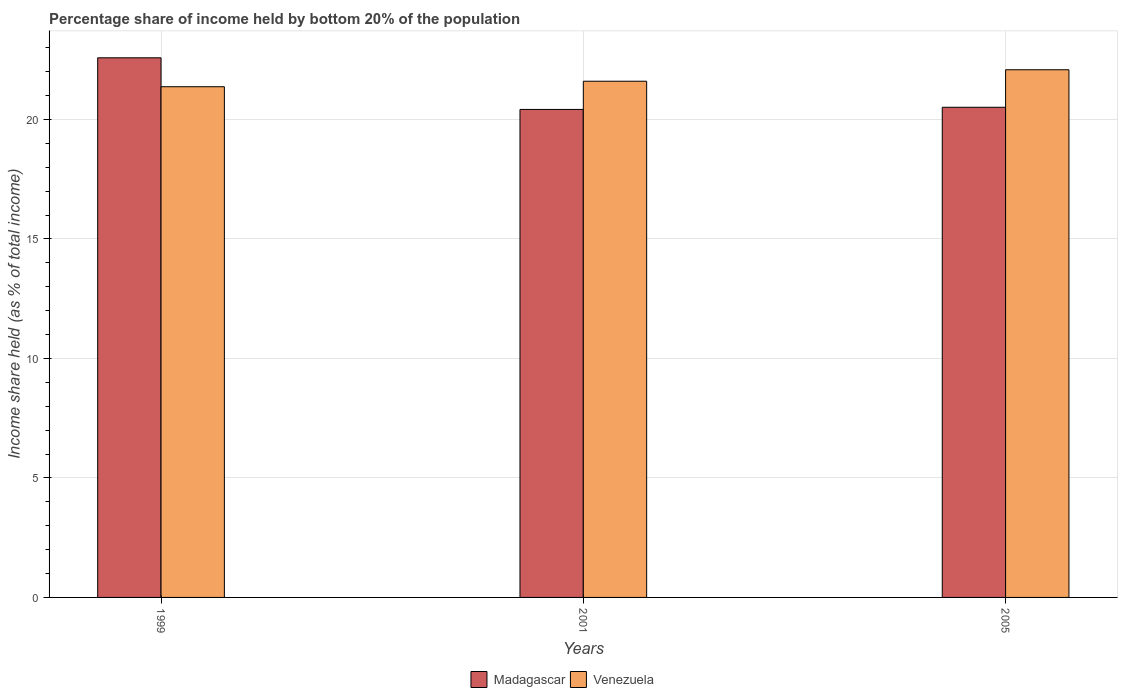Are the number of bars per tick equal to the number of legend labels?
Ensure brevity in your answer.  Yes. How many bars are there on the 3rd tick from the left?
Offer a terse response. 2. In how many cases, is the number of bars for a given year not equal to the number of legend labels?
Give a very brief answer. 0. What is the share of income held by bottom 20% of the population in Madagascar in 2005?
Offer a terse response. 20.51. Across all years, what is the maximum share of income held by bottom 20% of the population in Venezuela?
Your answer should be very brief. 22.08. Across all years, what is the minimum share of income held by bottom 20% of the population in Venezuela?
Your answer should be compact. 21.37. In which year was the share of income held by bottom 20% of the population in Venezuela maximum?
Ensure brevity in your answer.  2005. In which year was the share of income held by bottom 20% of the population in Madagascar minimum?
Your answer should be very brief. 2001. What is the total share of income held by bottom 20% of the population in Venezuela in the graph?
Give a very brief answer. 65.05. What is the difference between the share of income held by bottom 20% of the population in Madagascar in 1999 and that in 2001?
Make the answer very short. 2.16. What is the difference between the share of income held by bottom 20% of the population in Madagascar in 2005 and the share of income held by bottom 20% of the population in Venezuela in 2001?
Give a very brief answer. -1.09. What is the average share of income held by bottom 20% of the population in Venezuela per year?
Ensure brevity in your answer.  21.68. In the year 2005, what is the difference between the share of income held by bottom 20% of the population in Venezuela and share of income held by bottom 20% of the population in Madagascar?
Give a very brief answer. 1.57. In how many years, is the share of income held by bottom 20% of the population in Venezuela greater than 18 %?
Give a very brief answer. 3. What is the ratio of the share of income held by bottom 20% of the population in Venezuela in 1999 to that in 2005?
Ensure brevity in your answer.  0.97. Is the share of income held by bottom 20% of the population in Madagascar in 1999 less than that in 2001?
Your answer should be compact. No. Is the difference between the share of income held by bottom 20% of the population in Venezuela in 1999 and 2005 greater than the difference between the share of income held by bottom 20% of the population in Madagascar in 1999 and 2005?
Provide a short and direct response. No. What is the difference between the highest and the second highest share of income held by bottom 20% of the population in Venezuela?
Ensure brevity in your answer.  0.48. What is the difference between the highest and the lowest share of income held by bottom 20% of the population in Venezuela?
Keep it short and to the point. 0.71. Is the sum of the share of income held by bottom 20% of the population in Venezuela in 1999 and 2001 greater than the maximum share of income held by bottom 20% of the population in Madagascar across all years?
Your answer should be very brief. Yes. What does the 1st bar from the left in 1999 represents?
Provide a short and direct response. Madagascar. What does the 2nd bar from the right in 1999 represents?
Provide a short and direct response. Madagascar. How many years are there in the graph?
Give a very brief answer. 3. How are the legend labels stacked?
Make the answer very short. Horizontal. What is the title of the graph?
Your answer should be compact. Percentage share of income held by bottom 20% of the population. Does "Burkina Faso" appear as one of the legend labels in the graph?
Your answer should be compact. No. What is the label or title of the Y-axis?
Offer a terse response. Income share held (as % of total income). What is the Income share held (as % of total income) of Madagascar in 1999?
Give a very brief answer. 22.58. What is the Income share held (as % of total income) in Venezuela in 1999?
Ensure brevity in your answer.  21.37. What is the Income share held (as % of total income) in Madagascar in 2001?
Your response must be concise. 20.42. What is the Income share held (as % of total income) of Venezuela in 2001?
Your answer should be compact. 21.6. What is the Income share held (as % of total income) of Madagascar in 2005?
Your response must be concise. 20.51. What is the Income share held (as % of total income) in Venezuela in 2005?
Keep it short and to the point. 22.08. Across all years, what is the maximum Income share held (as % of total income) in Madagascar?
Offer a very short reply. 22.58. Across all years, what is the maximum Income share held (as % of total income) in Venezuela?
Your answer should be compact. 22.08. Across all years, what is the minimum Income share held (as % of total income) in Madagascar?
Your answer should be compact. 20.42. Across all years, what is the minimum Income share held (as % of total income) of Venezuela?
Your response must be concise. 21.37. What is the total Income share held (as % of total income) of Madagascar in the graph?
Offer a terse response. 63.51. What is the total Income share held (as % of total income) of Venezuela in the graph?
Offer a very short reply. 65.05. What is the difference between the Income share held (as % of total income) in Madagascar in 1999 and that in 2001?
Provide a short and direct response. 2.16. What is the difference between the Income share held (as % of total income) in Venezuela in 1999 and that in 2001?
Give a very brief answer. -0.23. What is the difference between the Income share held (as % of total income) of Madagascar in 1999 and that in 2005?
Provide a short and direct response. 2.07. What is the difference between the Income share held (as % of total income) of Venezuela in 1999 and that in 2005?
Give a very brief answer. -0.71. What is the difference between the Income share held (as % of total income) of Madagascar in 2001 and that in 2005?
Provide a short and direct response. -0.09. What is the difference between the Income share held (as % of total income) in Venezuela in 2001 and that in 2005?
Give a very brief answer. -0.48. What is the difference between the Income share held (as % of total income) in Madagascar in 1999 and the Income share held (as % of total income) in Venezuela in 2001?
Your answer should be very brief. 0.98. What is the difference between the Income share held (as % of total income) of Madagascar in 1999 and the Income share held (as % of total income) of Venezuela in 2005?
Your response must be concise. 0.5. What is the difference between the Income share held (as % of total income) of Madagascar in 2001 and the Income share held (as % of total income) of Venezuela in 2005?
Give a very brief answer. -1.66. What is the average Income share held (as % of total income) of Madagascar per year?
Offer a terse response. 21.17. What is the average Income share held (as % of total income) in Venezuela per year?
Make the answer very short. 21.68. In the year 1999, what is the difference between the Income share held (as % of total income) of Madagascar and Income share held (as % of total income) of Venezuela?
Offer a very short reply. 1.21. In the year 2001, what is the difference between the Income share held (as % of total income) of Madagascar and Income share held (as % of total income) of Venezuela?
Ensure brevity in your answer.  -1.18. In the year 2005, what is the difference between the Income share held (as % of total income) of Madagascar and Income share held (as % of total income) of Venezuela?
Make the answer very short. -1.57. What is the ratio of the Income share held (as % of total income) of Madagascar in 1999 to that in 2001?
Provide a short and direct response. 1.11. What is the ratio of the Income share held (as % of total income) of Madagascar in 1999 to that in 2005?
Make the answer very short. 1.1. What is the ratio of the Income share held (as % of total income) in Venezuela in 1999 to that in 2005?
Provide a succinct answer. 0.97. What is the ratio of the Income share held (as % of total income) of Venezuela in 2001 to that in 2005?
Your answer should be very brief. 0.98. What is the difference between the highest and the second highest Income share held (as % of total income) in Madagascar?
Offer a very short reply. 2.07. What is the difference between the highest and the second highest Income share held (as % of total income) of Venezuela?
Provide a succinct answer. 0.48. What is the difference between the highest and the lowest Income share held (as % of total income) of Madagascar?
Keep it short and to the point. 2.16. What is the difference between the highest and the lowest Income share held (as % of total income) of Venezuela?
Ensure brevity in your answer.  0.71. 